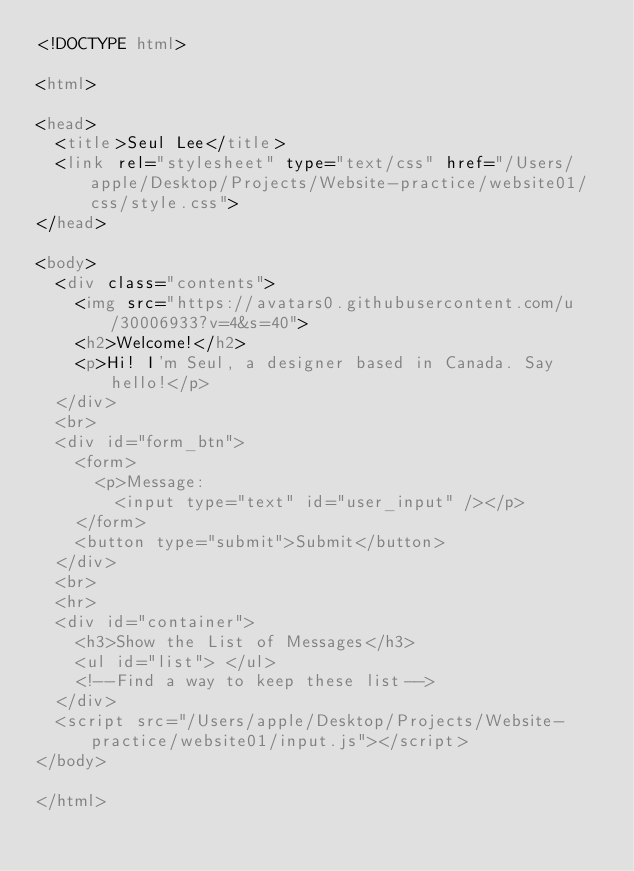<code> <loc_0><loc_0><loc_500><loc_500><_HTML_><!DOCTYPE html>

<html>

<head>
  <title>Seul Lee</title>
  <link rel="stylesheet" type="text/css" href="/Users/apple/Desktop/Projects/Website-practice/website01/css/style.css">
</head>

<body>
  <div class="contents">
    <img src="https://avatars0.githubusercontent.com/u/30006933?v=4&s=40">
    <h2>Welcome!</h2>
    <p>Hi! I'm Seul, a designer based in Canada. Say hello!</p>
  </div>
  <br>
  <div id="form_btn">
    <form>
      <p>Message:
        <input type="text" id="user_input" /></p>
    </form>
    <button type="submit">Submit</button>
  </div>
  <br>
  <hr>
  <div id="container">
    <h3>Show the List of Messages</h3>
    <ul id="list"> </ul>
    <!--Find a way to keep these list-->
  </div>
  <script src="/Users/apple/Desktop/Projects/Website-practice/website01/input.js"></script>
</body>

</html>
</code> 